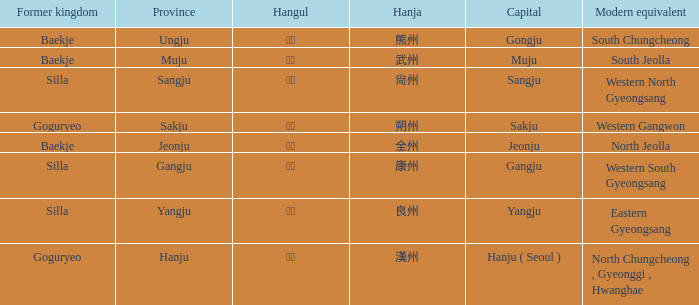What is the hanja for the territory of "sangju"? 尙州. 